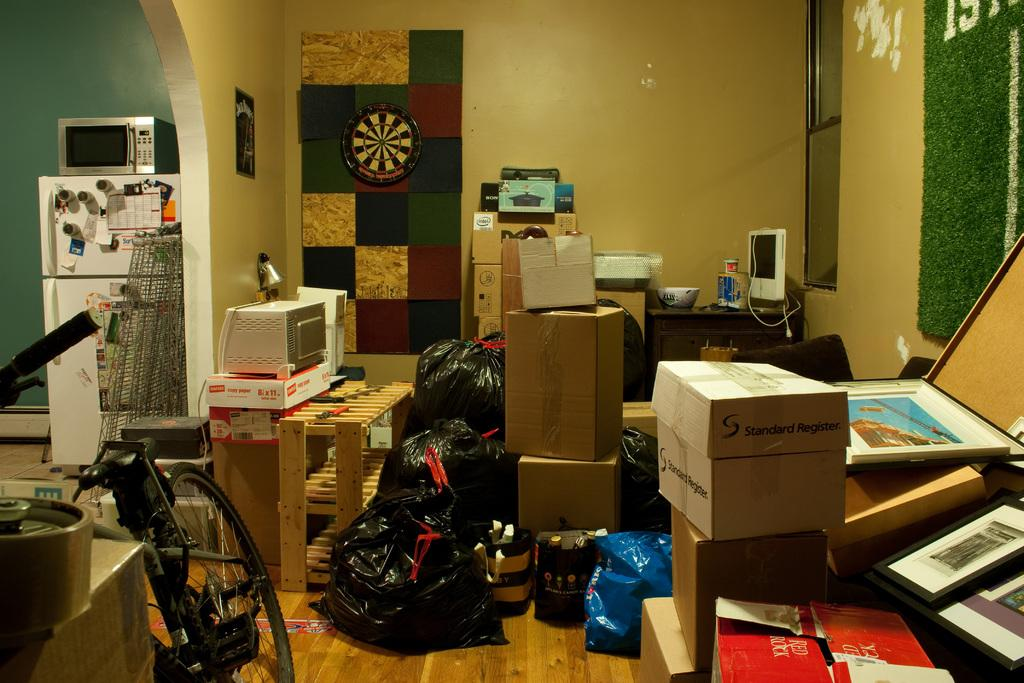What is the main surface visible in the image? There is a floor in the image. What type of vehicle is on the floor? A bicycle is present on the floor. What other items can be seen on the floor? There are boxes, photo frames, and plastic bags on the floor. Are there any other objects on the floor? Yes, there are other objects on the floor. What can be seen in the background of the image? There is a wall and a window in the background of the image. Can you tell me how many giraffes are visible through the window in the image? There are no giraffes visible through the window in the image. What type of gate is present in the image? There is no gate present in the image. 